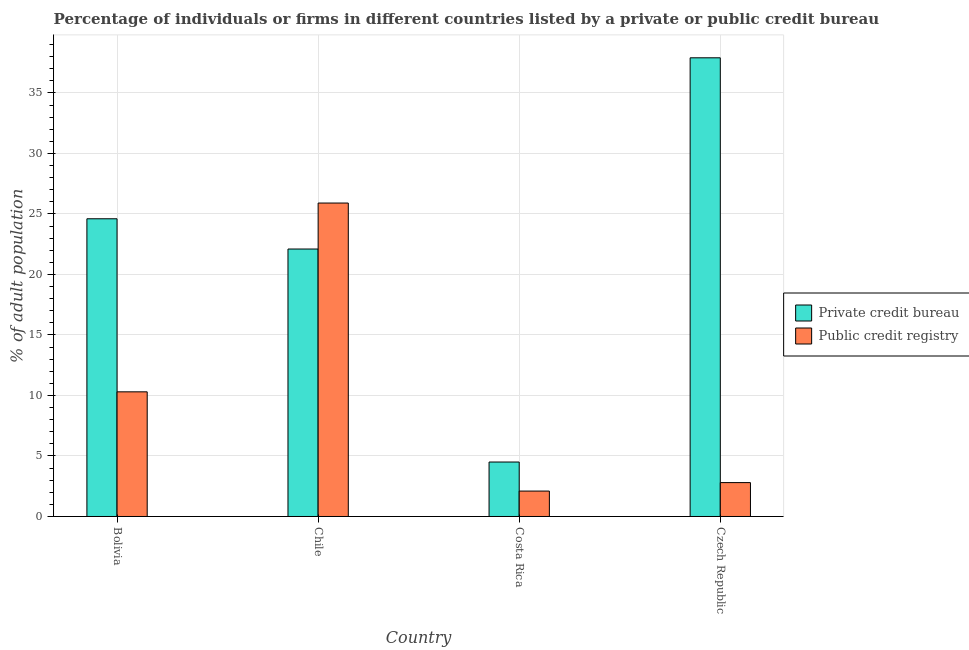How many groups of bars are there?
Provide a short and direct response. 4. How many bars are there on the 2nd tick from the left?
Make the answer very short. 2. How many bars are there on the 3rd tick from the right?
Your answer should be compact. 2. What is the label of the 4th group of bars from the left?
Your answer should be very brief. Czech Republic. In how many cases, is the number of bars for a given country not equal to the number of legend labels?
Your response must be concise. 0. Across all countries, what is the maximum percentage of firms listed by private credit bureau?
Ensure brevity in your answer.  37.9. What is the total percentage of firms listed by public credit bureau in the graph?
Your answer should be very brief. 41.1. What is the difference between the percentage of firms listed by public credit bureau in Costa Rica and that in Czech Republic?
Your response must be concise. -0.7. What is the difference between the percentage of firms listed by public credit bureau in Bolivia and the percentage of firms listed by private credit bureau in Czech Republic?
Your answer should be very brief. -27.6. What is the average percentage of firms listed by public credit bureau per country?
Your answer should be compact. 10.28. What is the difference between the percentage of firms listed by private credit bureau and percentage of firms listed by public credit bureau in Costa Rica?
Ensure brevity in your answer.  2.4. In how many countries, is the percentage of firms listed by private credit bureau greater than 30 %?
Your answer should be very brief. 1. What is the ratio of the percentage of firms listed by private credit bureau in Costa Rica to that in Czech Republic?
Provide a short and direct response. 0.12. Is the percentage of firms listed by public credit bureau in Bolivia less than that in Chile?
Your answer should be compact. Yes. What is the difference between the highest and the second highest percentage of firms listed by public credit bureau?
Offer a terse response. 15.6. What is the difference between the highest and the lowest percentage of firms listed by public credit bureau?
Ensure brevity in your answer.  23.8. Is the sum of the percentage of firms listed by private credit bureau in Bolivia and Costa Rica greater than the maximum percentage of firms listed by public credit bureau across all countries?
Your answer should be compact. Yes. What does the 1st bar from the left in Costa Rica represents?
Offer a very short reply. Private credit bureau. What does the 1st bar from the right in Bolivia represents?
Your response must be concise. Public credit registry. How many bars are there?
Your answer should be compact. 8. What is the difference between two consecutive major ticks on the Y-axis?
Your answer should be compact. 5. Are the values on the major ticks of Y-axis written in scientific E-notation?
Keep it short and to the point. No. Does the graph contain grids?
Make the answer very short. Yes. How many legend labels are there?
Your response must be concise. 2. What is the title of the graph?
Provide a short and direct response. Percentage of individuals or firms in different countries listed by a private or public credit bureau. Does "Export" appear as one of the legend labels in the graph?
Your response must be concise. No. What is the label or title of the Y-axis?
Provide a short and direct response. % of adult population. What is the % of adult population of Private credit bureau in Bolivia?
Offer a very short reply. 24.6. What is the % of adult population of Private credit bureau in Chile?
Your answer should be very brief. 22.1. What is the % of adult population in Public credit registry in Chile?
Keep it short and to the point. 25.9. What is the % of adult population of Public credit registry in Costa Rica?
Offer a terse response. 2.1. What is the % of adult population in Private credit bureau in Czech Republic?
Make the answer very short. 37.9. What is the % of adult population of Public credit registry in Czech Republic?
Give a very brief answer. 2.8. Across all countries, what is the maximum % of adult population in Private credit bureau?
Ensure brevity in your answer.  37.9. Across all countries, what is the maximum % of adult population of Public credit registry?
Your answer should be very brief. 25.9. What is the total % of adult population in Private credit bureau in the graph?
Give a very brief answer. 89.1. What is the total % of adult population in Public credit registry in the graph?
Keep it short and to the point. 41.1. What is the difference between the % of adult population of Private credit bureau in Bolivia and that in Chile?
Your response must be concise. 2.5. What is the difference between the % of adult population in Public credit registry in Bolivia and that in Chile?
Provide a short and direct response. -15.6. What is the difference between the % of adult population in Private credit bureau in Bolivia and that in Costa Rica?
Give a very brief answer. 20.1. What is the difference between the % of adult population of Private credit bureau in Bolivia and that in Czech Republic?
Keep it short and to the point. -13.3. What is the difference between the % of adult population of Public credit registry in Bolivia and that in Czech Republic?
Provide a succinct answer. 7.5. What is the difference between the % of adult population of Private credit bureau in Chile and that in Costa Rica?
Your answer should be very brief. 17.6. What is the difference between the % of adult population in Public credit registry in Chile and that in Costa Rica?
Your answer should be very brief. 23.8. What is the difference between the % of adult population in Private credit bureau in Chile and that in Czech Republic?
Provide a short and direct response. -15.8. What is the difference between the % of adult population in Public credit registry in Chile and that in Czech Republic?
Give a very brief answer. 23.1. What is the difference between the % of adult population of Private credit bureau in Costa Rica and that in Czech Republic?
Keep it short and to the point. -33.4. What is the difference between the % of adult population in Private credit bureau in Bolivia and the % of adult population in Public credit registry in Chile?
Your answer should be compact. -1.3. What is the difference between the % of adult population in Private credit bureau in Bolivia and the % of adult population in Public credit registry in Czech Republic?
Offer a terse response. 21.8. What is the difference between the % of adult population of Private credit bureau in Chile and the % of adult population of Public credit registry in Costa Rica?
Offer a very short reply. 20. What is the difference between the % of adult population in Private credit bureau in Chile and the % of adult population in Public credit registry in Czech Republic?
Make the answer very short. 19.3. What is the difference between the % of adult population of Private credit bureau in Costa Rica and the % of adult population of Public credit registry in Czech Republic?
Give a very brief answer. 1.7. What is the average % of adult population of Private credit bureau per country?
Offer a terse response. 22.27. What is the average % of adult population in Public credit registry per country?
Give a very brief answer. 10.28. What is the difference between the % of adult population of Private credit bureau and % of adult population of Public credit registry in Chile?
Make the answer very short. -3.8. What is the difference between the % of adult population of Private credit bureau and % of adult population of Public credit registry in Czech Republic?
Make the answer very short. 35.1. What is the ratio of the % of adult population in Private credit bureau in Bolivia to that in Chile?
Your response must be concise. 1.11. What is the ratio of the % of adult population in Public credit registry in Bolivia to that in Chile?
Provide a short and direct response. 0.4. What is the ratio of the % of adult population of Private credit bureau in Bolivia to that in Costa Rica?
Provide a succinct answer. 5.47. What is the ratio of the % of adult population in Public credit registry in Bolivia to that in Costa Rica?
Provide a succinct answer. 4.9. What is the ratio of the % of adult population of Private credit bureau in Bolivia to that in Czech Republic?
Give a very brief answer. 0.65. What is the ratio of the % of adult population in Public credit registry in Bolivia to that in Czech Republic?
Your answer should be compact. 3.68. What is the ratio of the % of adult population in Private credit bureau in Chile to that in Costa Rica?
Provide a short and direct response. 4.91. What is the ratio of the % of adult population of Public credit registry in Chile to that in Costa Rica?
Offer a terse response. 12.33. What is the ratio of the % of adult population in Private credit bureau in Chile to that in Czech Republic?
Your answer should be compact. 0.58. What is the ratio of the % of adult population in Public credit registry in Chile to that in Czech Republic?
Your answer should be very brief. 9.25. What is the ratio of the % of adult population of Private credit bureau in Costa Rica to that in Czech Republic?
Your response must be concise. 0.12. What is the ratio of the % of adult population of Public credit registry in Costa Rica to that in Czech Republic?
Make the answer very short. 0.75. What is the difference between the highest and the second highest % of adult population in Public credit registry?
Your answer should be very brief. 15.6. What is the difference between the highest and the lowest % of adult population of Private credit bureau?
Your answer should be compact. 33.4. What is the difference between the highest and the lowest % of adult population of Public credit registry?
Provide a short and direct response. 23.8. 